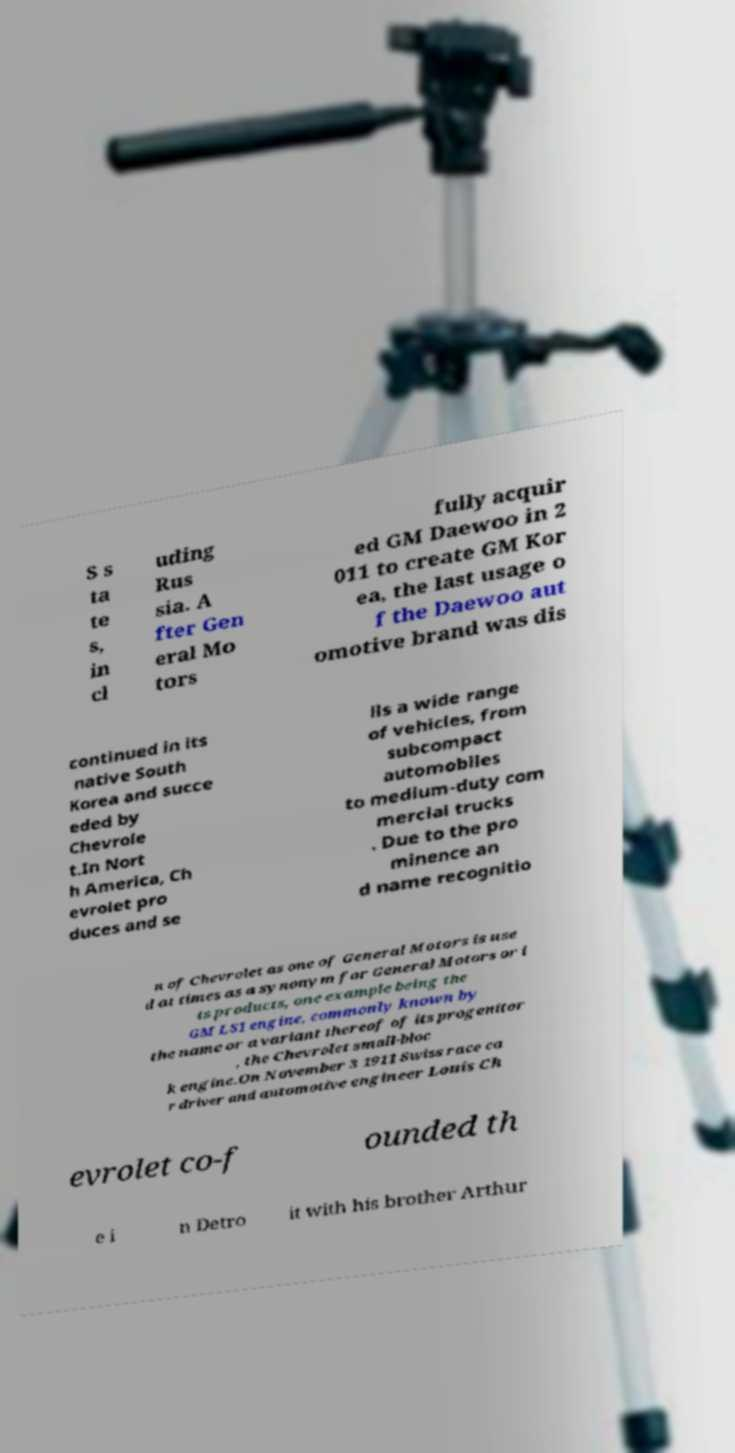Can you read and provide the text displayed in the image?This photo seems to have some interesting text. Can you extract and type it out for me? S s ta te s, in cl uding Rus sia. A fter Gen eral Mo tors fully acquir ed GM Daewoo in 2 011 to create GM Kor ea, the last usage o f the Daewoo aut omotive brand was dis continued in its native South Korea and succe eded by Chevrole t.In Nort h America, Ch evrolet pro duces and se lls a wide range of vehicles, from subcompact automobiles to medium-duty com mercial trucks . Due to the pro minence an d name recognitio n of Chevrolet as one of General Motors is use d at times as a synonym for General Motors or i ts products, one example being the GM LS1 engine, commonly known by the name or a variant thereof of its progenitor , the Chevrolet small-bloc k engine.On November 3 1911 Swiss race ca r driver and automotive engineer Louis Ch evrolet co-f ounded th e i n Detro it with his brother Arthur 